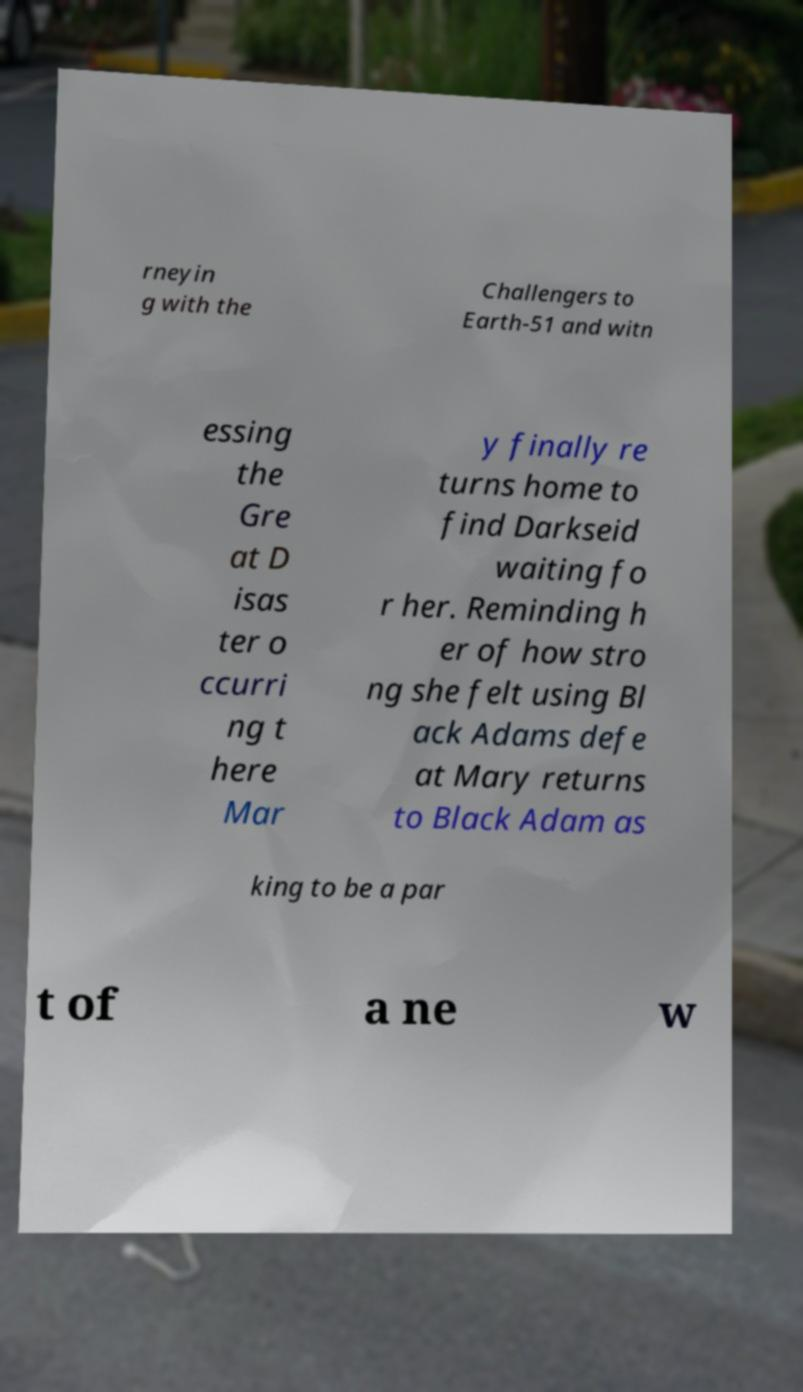Please read and relay the text visible in this image. What does it say? rneyin g with the Challengers to Earth-51 and witn essing the Gre at D isas ter o ccurri ng t here Mar y finally re turns home to find Darkseid waiting fo r her. Reminding h er of how stro ng she felt using Bl ack Adams defe at Mary returns to Black Adam as king to be a par t of a ne w 